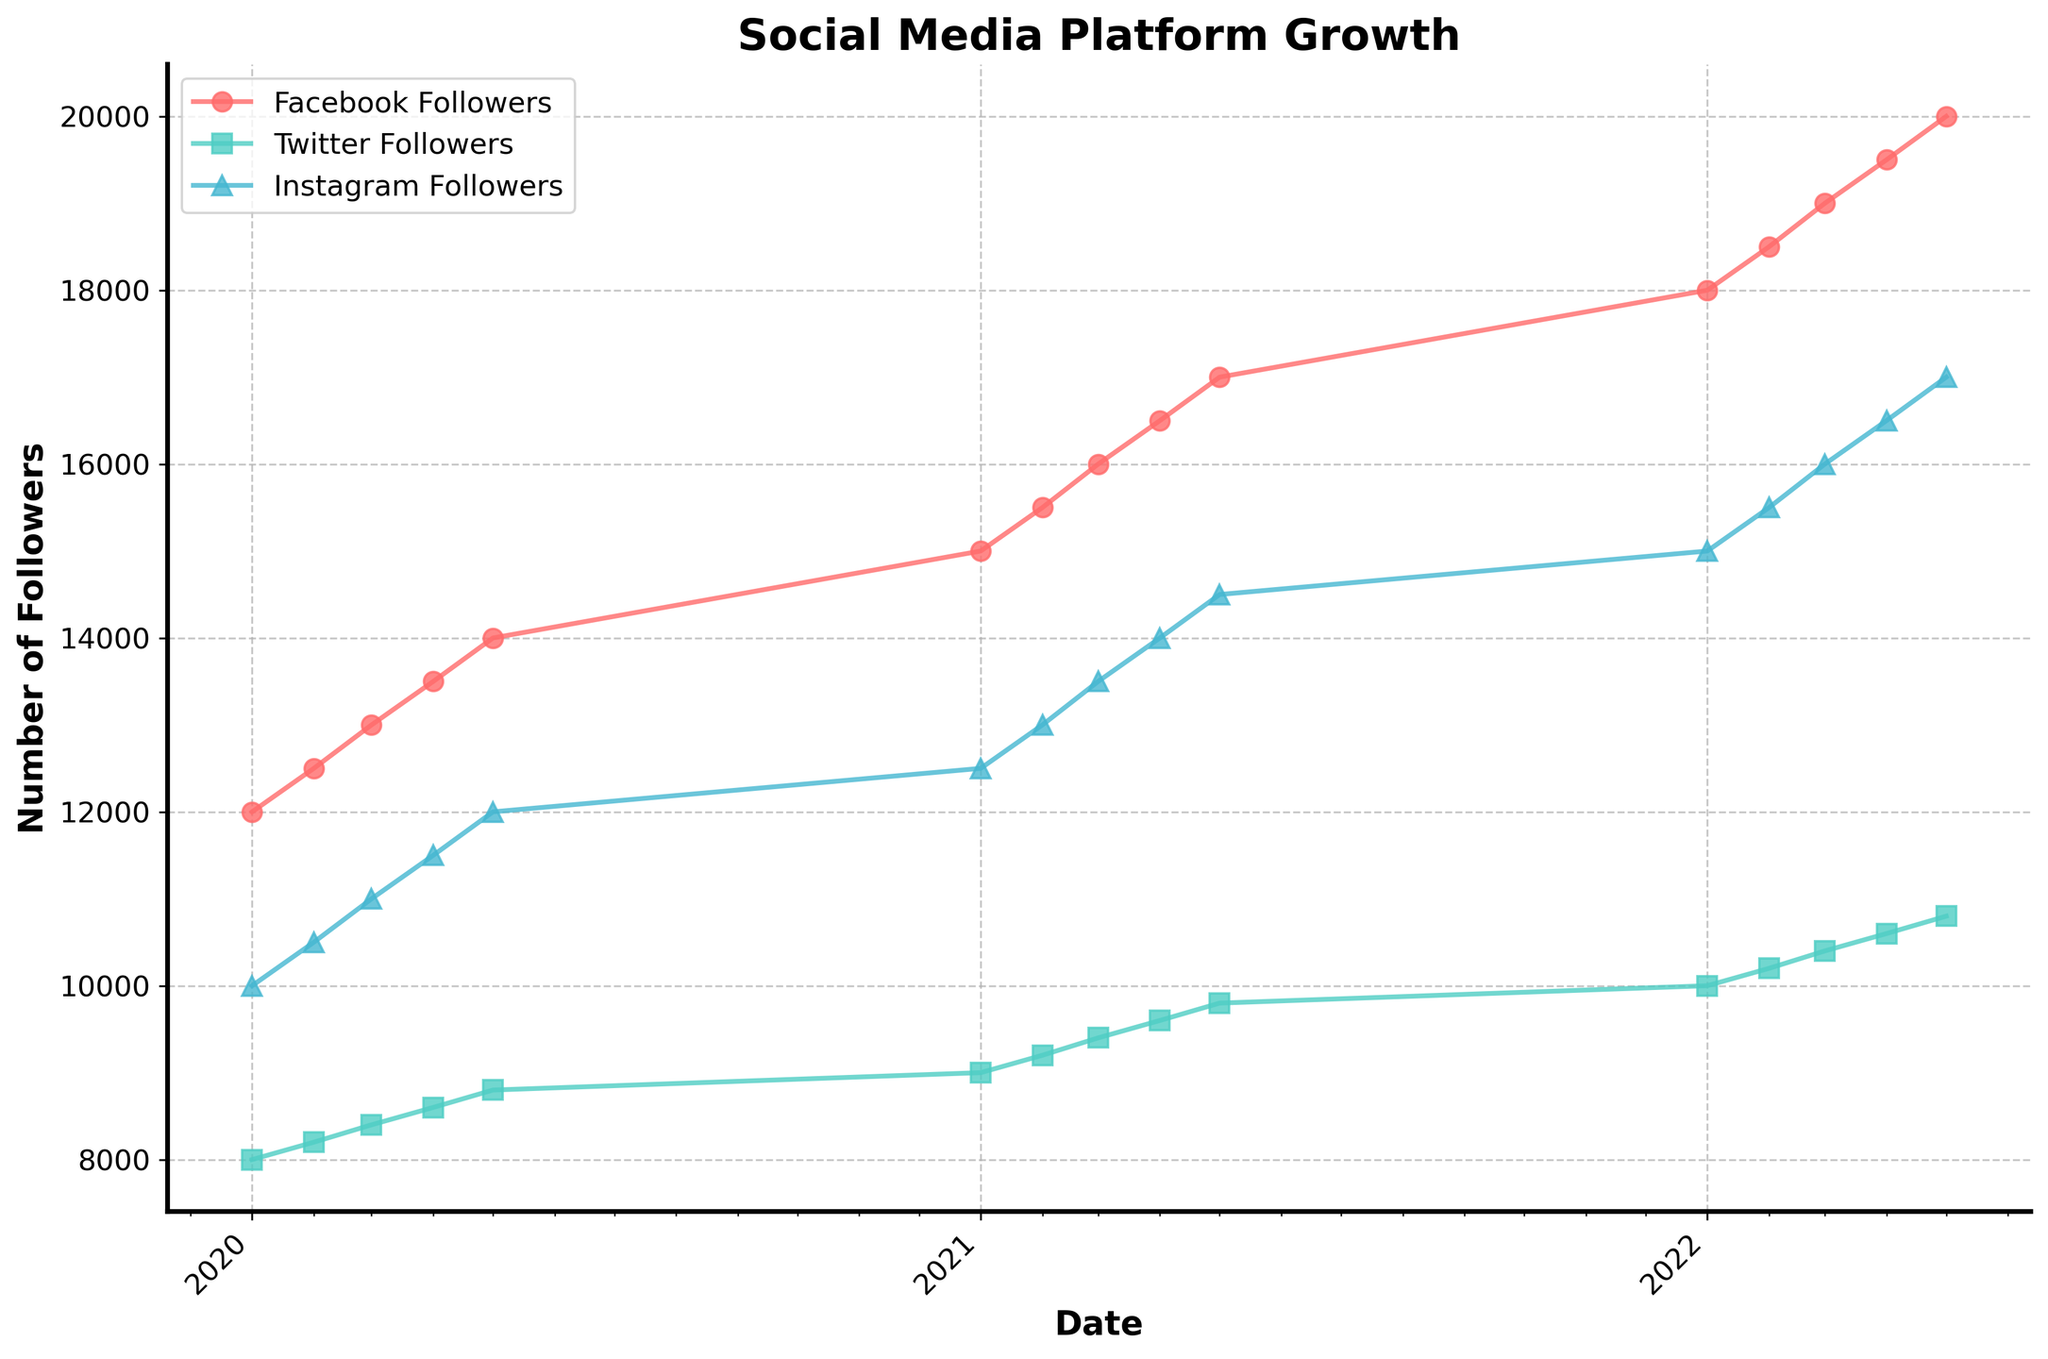What is the title of the figure? The title of the figure is displayed at the top of the plot.
Answer: Social Media Platform Growth How many different social media platforms are represented in the plot? The legend and lines on the plot represent the different social media platforms.
Answer: Three Between Facebook and Twitter, which platform had the highest number of followers at the start of 2022? Locate the closest points to January 2022 for both Facebook and Twitter and compare their follower numbers.
Answer: Facebook What trend do you observe in the number of followers for Instagram over the three-year period? Look at the line representing Instagram and observe its slope and changes over time.
Answer: Increase What's the difference in the number of Instagram followers between January 2021 and May 2022? Find the points on the Instagram line for January 2021 and May 2022, then subtract the former from the latter.
Answer: 4,500 In which year did Facebook see the first appearance of 20,000 followers? Follow the trend line for Facebook and identify the year when the 20,000-follower mark is reached.
Answer: 2022 Which platform shows the most consistent growth in followers based on the slope of the lines? Identify the line with the most uniform slope without abrupt changes.
Answer: Instagram How does the growth in followers for Twitter compare to Facebook from 2020 to 2022? Analyze the slope and distance covered by both lines over the given period.
Answer: Slower By the end of the visualization period, which platform had the fewest followers? Look at the data points closest to the last date in the figure for all three platforms and compare their follower numbers.
Answer: Twitter 